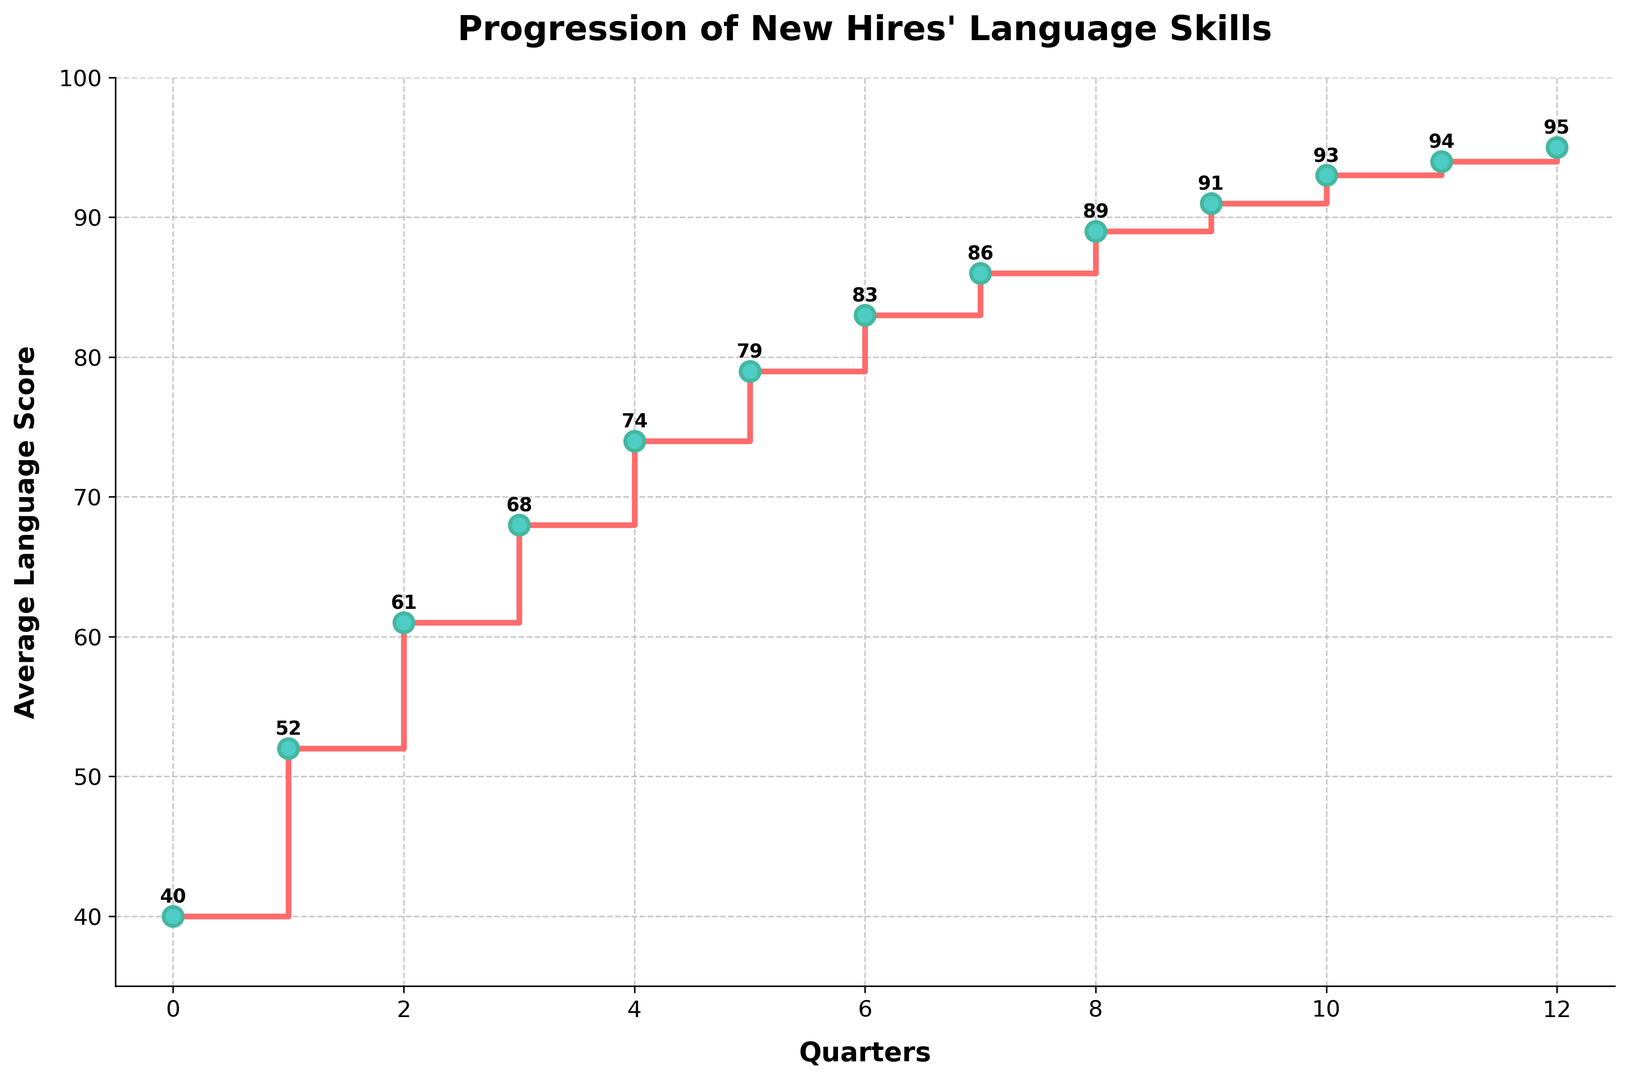What is the average language score at the end of the first quarter? The first quarter corresponds to Quarter 1 in the data, where the average language score is given in the figure.
Answer: 52 How much did the average language score increase from Quarter 2 to Quarter 6? Quarter 2 has an average score of 61, and Quarter 6 has an average score of 83. The increase is calculated by subtracting the score of Quarter 2 from that of Quarter 6: 83 - 61.
Answer: 22 Which quarter shows the highest increase in the average language score compared to its previous quarter? To find the highest increase, we need to look at the differences between consecutive quarters: 52-40, 61-52, 68-61, 74-68, 79-74, 83-79, 86-83, 89-86, 91-89, 93-91, 94-93, 95-94. The largest increase is seen between Quarter 0 and Quarter 1.
Answer: Quarter 1 At what quarter does the average language score first exceed 80? We can see in the figure that the average language score first exceeds 80 at Quarter 6.
Answer: Quarter 6 Is the increase in average language scores consistent over all quarters, or are there periods of rapid or slow growth? Identify them. We need to compare the differences between consecutive quarters. Most quarters show consistent increases, but rapid growth is seen from Quarter 0 to Quarter 1, and slower growth from Quarter 10 to Quarter 12.
Answer: Mostly consistent with rapid growth at early stages and slower growth at later stages By how many points did the average language score improve from the beginning to the end of the first year? The beginning is Quarter 0 with a score of 40, and the end of the first year is Quarter 12 with a score of 95. The improvement is 95 - 40.
Answer: 55 